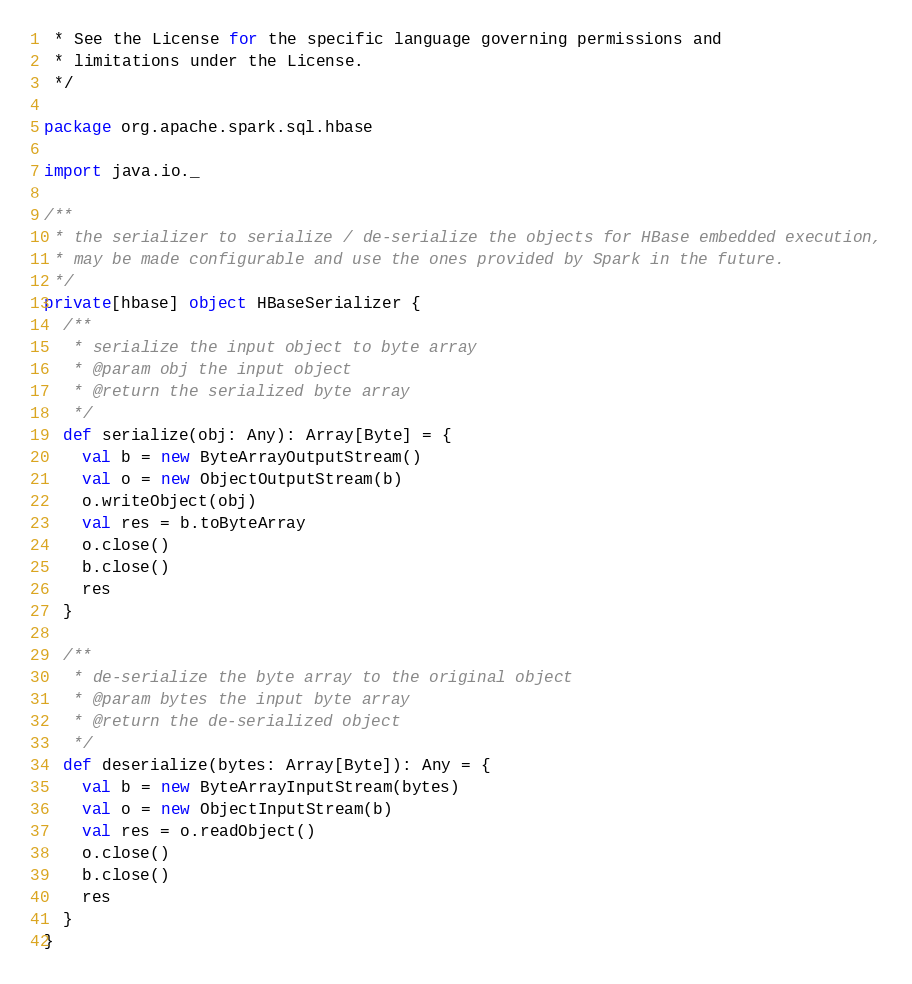Convert code to text. <code><loc_0><loc_0><loc_500><loc_500><_Scala_> * See the License for the specific language governing permissions and
 * limitations under the License.
 */

package org.apache.spark.sql.hbase

import java.io._

/**
 * the serializer to serialize / de-serialize the objects for HBase embedded execution,
 * may be made configurable and use the ones provided by Spark in the future.
 */
private[hbase] object HBaseSerializer {
  /**
   * serialize the input object to byte array
   * @param obj the input object
   * @return the serialized byte array
   */
  def serialize(obj: Any): Array[Byte] = {
    val b = new ByteArrayOutputStream()
    val o = new ObjectOutputStream(b)
    o.writeObject(obj)
    val res = b.toByteArray
    o.close()
    b.close()
    res
  }

  /**
   * de-serialize the byte array to the original object
   * @param bytes the input byte array
   * @return the de-serialized object
   */
  def deserialize(bytes: Array[Byte]): Any = {
    val b = new ByteArrayInputStream(bytes)
    val o = new ObjectInputStream(b)
    val res = o.readObject()
    o.close()
    b.close()
    res
  }
}
</code> 